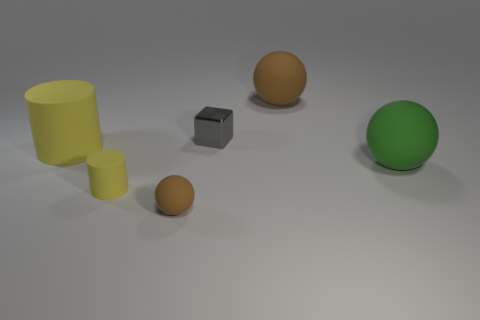Add 1 green metallic objects. How many objects exist? 7 Subtract all blocks. How many objects are left? 5 Add 2 brown balls. How many brown balls are left? 4 Add 3 rubber balls. How many rubber balls exist? 6 Subtract 0 cyan cylinders. How many objects are left? 6 Subtract all yellow objects. Subtract all green objects. How many objects are left? 3 